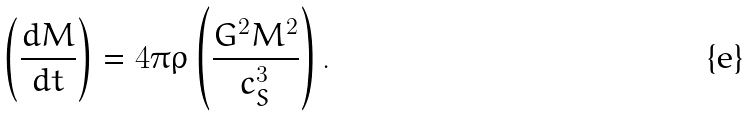<formula> <loc_0><loc_0><loc_500><loc_500>\left ( \frac { d M } { d t } \right ) = 4 \pi \rho \left ( \frac { G ^ { 2 } M ^ { 2 } } { c _ { S } ^ { 3 } } \right ) .</formula> 